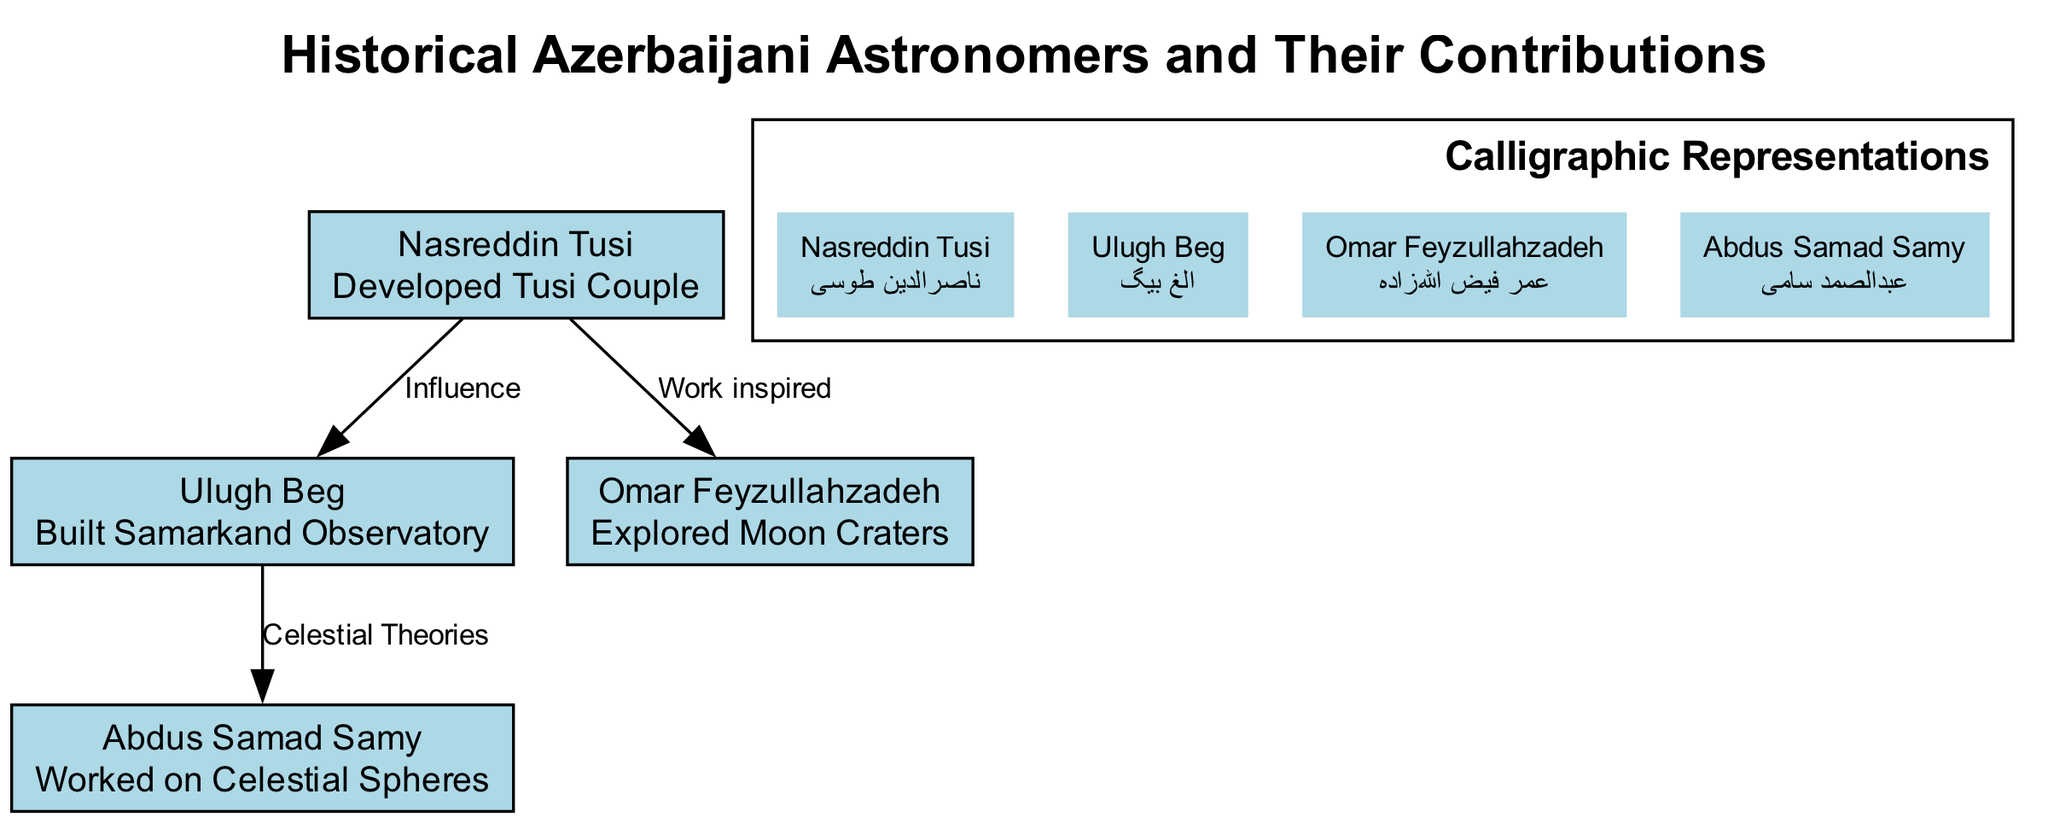What is the total number of nodes in the diagram? The diagram contains four nodes representing historical Azerbaijani astronomers: Nasreddin Tusi, Ulugh Beg, Omar Feyzullahzadeh, and Abdus Samad Samy. Thus, the total number of nodes is four.
Answer: 4 Who is described as having developed the Tusi Couple? The node labeled "Nasreddin Tusi" is linked to the description that states he "Developed Tusi Couple." This indicates that Nasreddin Tusi is the correct answer.
Answer: Nasreddin Tusi How many relationships are indicated by the edges in the diagram? There are three edges shown in the diagram which represent relationships or influences between the nodes. Therefore, the number of relationships is three.
Answer: 3 Which astronomer was influenced by Nasreddin Tusi? The diagram shows an edge labeled "Influence" from Nasreddin Tusi to Ulugh Beg, indicating that Ulugh Beg was influenced by him. Therefore, Ulugh Beg is the answer.
Answer: Ulugh Beg What type of work did Omar Feyzullahzadeh focus on? The node for Omar Feyzullahzadeh states he "Explored Moon Craters." This clearly identifies the focus of his work.
Answer: Explored Moon Craters What celestial theories were influenced by Ulugh Beg? The edge labeled "Celestial Theories" connects Ulugh Beg to Abdus Samad Samy. This indicates that Abdus Samad Samy worked on celestial theories that were influenced by Ulugh Beg.
Answer: Celestial Theories Which language is used for the calligraphic representation of the astronomers? The calligraphy section of the diagram mentions "Persian Calligraphy" as the style used for the representations of the astronomers' names. Accordingly, the answer is Persian.
Answer: Persian How does Omar Feyzullahzadeh relate to Nasreddin Tusi in the context of their work? The diagram shows an edge from Nasreddin Tusi to Omar Feyzullahzadeh labeled "Work inspired," indicating that Nasreddin Tusi inspired the work of Omar Feyzullahzadeh, which connects them in the context of inspiration.
Answer: Work inspired Which astronomer contributed to the construction of the Samarkand Observatory? The node labeled "Ulugh Beg" carries the description stating he "Built Samarkand Observatory," making him the contributor in question.
Answer: Ulugh Beg 